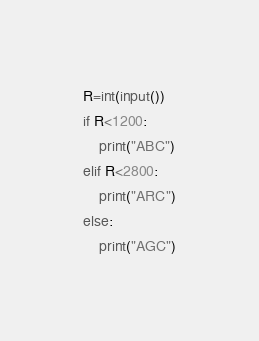<code> <loc_0><loc_0><loc_500><loc_500><_Python_>R=int(input())
if R<1200:
    print("ABC")
elif R<2800:
    print("ARC")
else:
    print("AGC")
</code> 